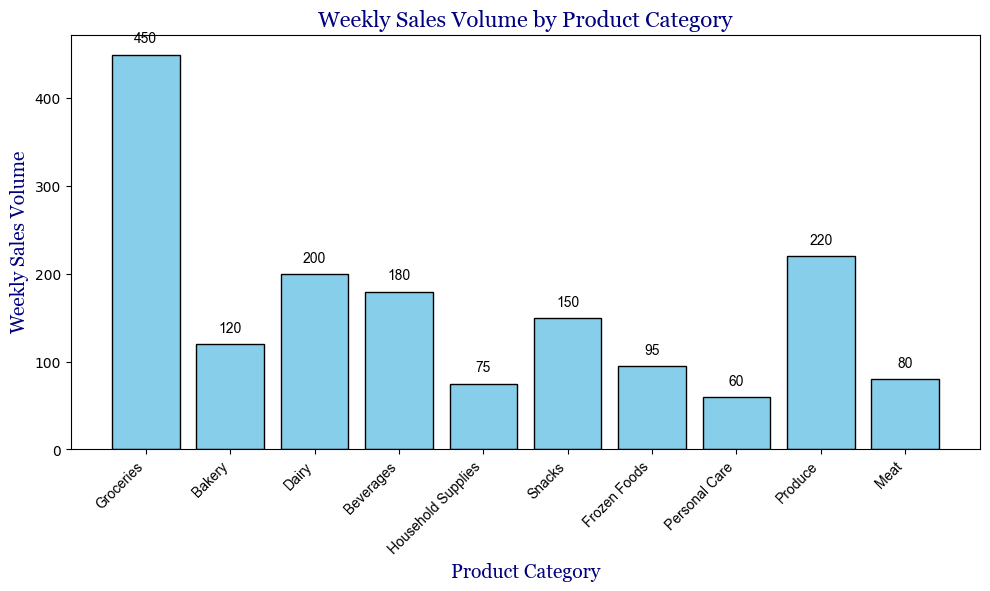Which product category has the highest weekly sales volume? The bar for Groceries is the tallest among all categories, indicating the highest volume.
Answer: Groceries What's the total weekly sales volume for Groceries and Bakery? The weekly sales volumes for Groceries and Bakery are 450 and 120, respectively. Adding them gives 450 + 120 = 570.
Answer: 570 What is the difference in weekly sales volume between Produce and Snacks? Produce has a sales volume of 220 and Snacks have 150. The difference is 220 - 150 = 70.
Answer: 70 Which product category has the smallest weekly sales volume? The bar for Personal Care is the shortest among all categories, indicating the smallest weekly sales volume.
Answer: Personal Care Is the weekly sales volume of Beverages greater than that of Dairy? The weekly sales volume of Beverages is 180, and for Dairy, it is 200. So, no, Beverages is not greater than Dairy.
Answer: No What is the average weekly sales volume across all product categories? First find the total sales volume by adding all individual volumes: (450 + 120 + 200 + 180 + 75 + 150 + 95 + 60 + 220 + 80) = 1630. There are 10 categories, so the average is 1630 / 10 = 163.
Answer: 163 How many product categories have a weekly sales volume greater than 100? By looking at the bars, the categories Groceries, Bakery, Dairy, Beverages, Snacks, and Produce have sales volumes greater than 100. There are 6 such categories.
Answer: 6 Which product category has a higher weekly sales volume, Frozen Foods or Meat? Looking at the heights of the bars, Frozen Foods has a weekly sales volume of 95 and Meat has 80. Frozen Foods is higher.
Answer: Frozen Foods 